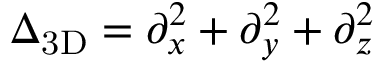<formula> <loc_0><loc_0><loc_500><loc_500>\Delta _ { 3 D } = \partial _ { x } ^ { 2 } + \partial _ { y } ^ { 2 } + \partial _ { z } ^ { 2 }</formula> 